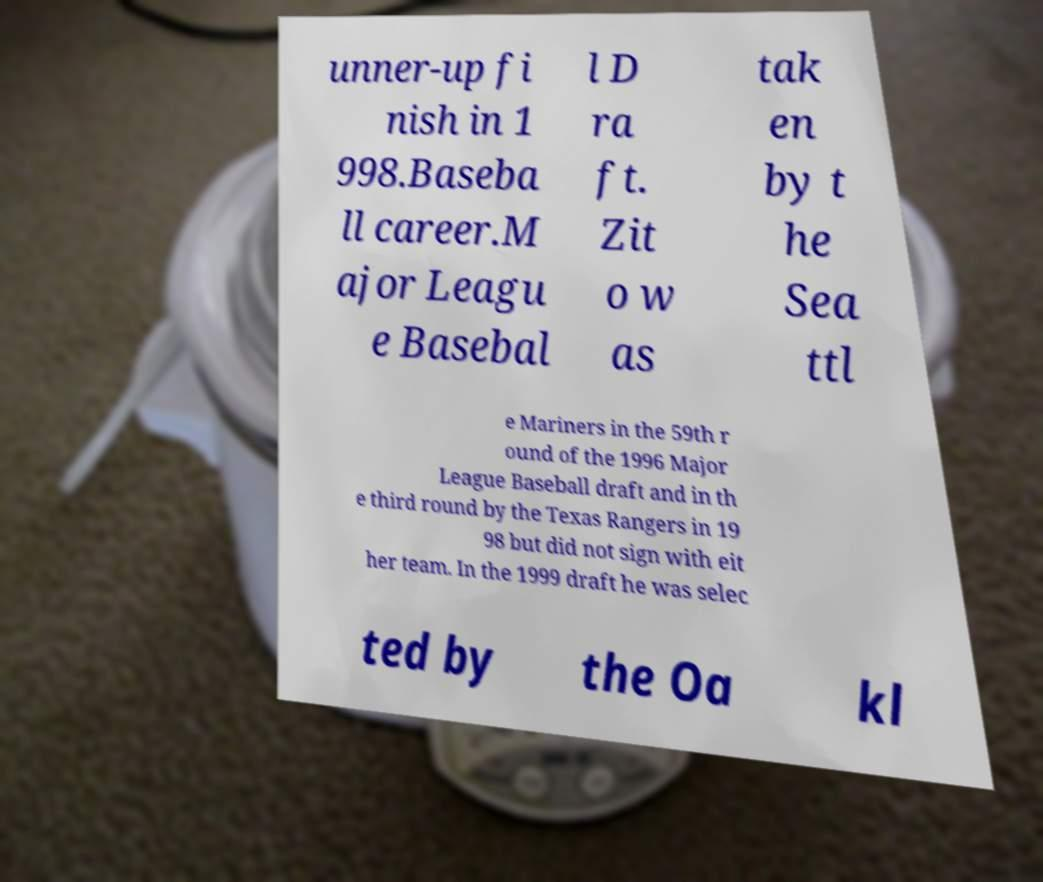Can you accurately transcribe the text from the provided image for me? unner-up fi nish in 1 998.Baseba ll career.M ajor Leagu e Basebal l D ra ft. Zit o w as tak en by t he Sea ttl e Mariners in the 59th r ound of the 1996 Major League Baseball draft and in th e third round by the Texas Rangers in 19 98 but did not sign with eit her team. In the 1999 draft he was selec ted by the Oa kl 